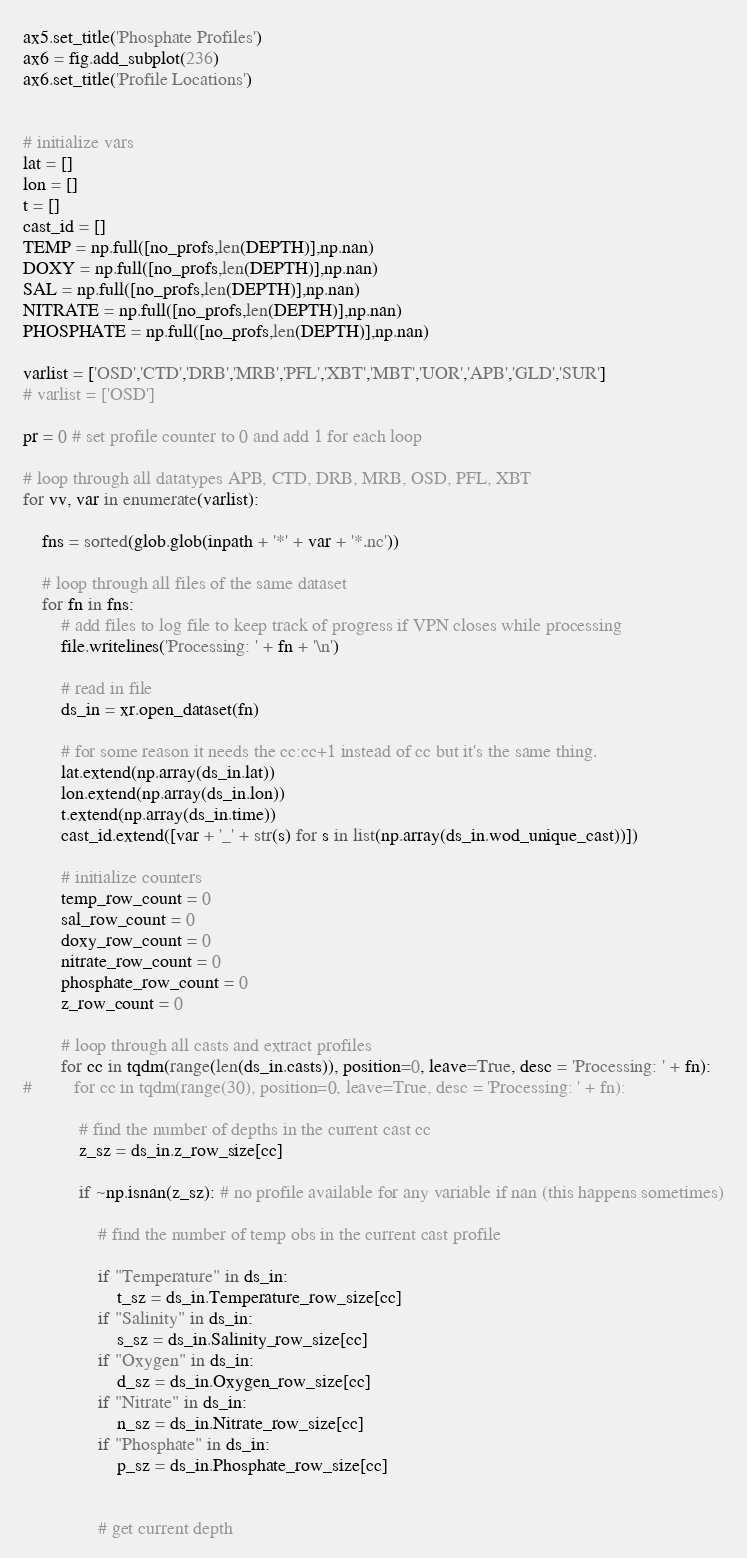<code> <loc_0><loc_0><loc_500><loc_500><_Python_>ax5.set_title('Phosphate Profiles')
ax6 = fig.add_subplot(236)
ax6.set_title('Profile Locations')


# initialize vars
lat = []
lon = []
t = []
cast_id = []
TEMP = np.full([no_profs,len(DEPTH)],np.nan)
DOXY = np.full([no_profs,len(DEPTH)],np.nan)
SAL = np.full([no_profs,len(DEPTH)],np.nan)
NITRATE = np.full([no_profs,len(DEPTH)],np.nan)
PHOSPHATE = np.full([no_profs,len(DEPTH)],np.nan)

varlist = ['OSD','CTD','DRB','MRB','PFL','XBT','MBT','UOR','APB','GLD','SUR']
# varlist = ['OSD']

pr = 0 # set profile counter to 0 and add 1 for each loop

# loop through all datatypes APB, CTD, DRB, MRB, OSD, PFL, XBT
for vv, var in enumerate(varlist):

    fns = sorted(glob.glob(inpath + '*' + var + '*.nc'))
    
    # loop through all files of the same dataset
    for fn in fns:
        # add files to log file to keep track of progress if VPN closes while processing
        file.writelines('Processing: ' + fn + '\n') 

        # read in file
        ds_in = xr.open_dataset(fn)
        
        # for some reason it needs the cc:cc+1 instead of cc but it's the same thing.
        lat.extend(np.array(ds_in.lat))
        lon.extend(np.array(ds_in.lon))
        t.extend(np.array(ds_in.time))
        cast_id.extend([var + '_' + str(s) for s in list(np.array(ds_in.wod_unique_cast))])

        # initialize counters
        temp_row_count = 0
        sal_row_count = 0
        doxy_row_count = 0
        nitrate_row_count = 0
        phosphate_row_count = 0
        z_row_count = 0

        # loop through all casts and extract profiles
        for cc in tqdm(range(len(ds_in.casts)), position=0, leave=True, desc = 'Processing: ' + fn):
#         for cc in tqdm(range(30), position=0, leave=True, desc = 'Processing: ' + fn):

            # find the number of depths in the current cast cc
            z_sz = ds_in.z_row_size[cc]

            if ~np.isnan(z_sz): # no profile available for any variable if nan (this happens sometimes)

                # find the number of temp obs in the current cast profile
                
                if "Temperature" in ds_in:
                    t_sz = ds_in.Temperature_row_size[cc]
                if "Salinity" in ds_in:
                    s_sz = ds_in.Salinity_row_size[cc]
                if "Oxygen" in ds_in:
                    d_sz = ds_in.Oxygen_row_size[cc]
                if "Nitrate" in ds_in:
                    n_sz = ds_in.Nitrate_row_size[cc]
                if "Phosphate" in ds_in:
                    p_sz = ds_in.Phosphate_row_size[cc]


                # get current depth</code> 